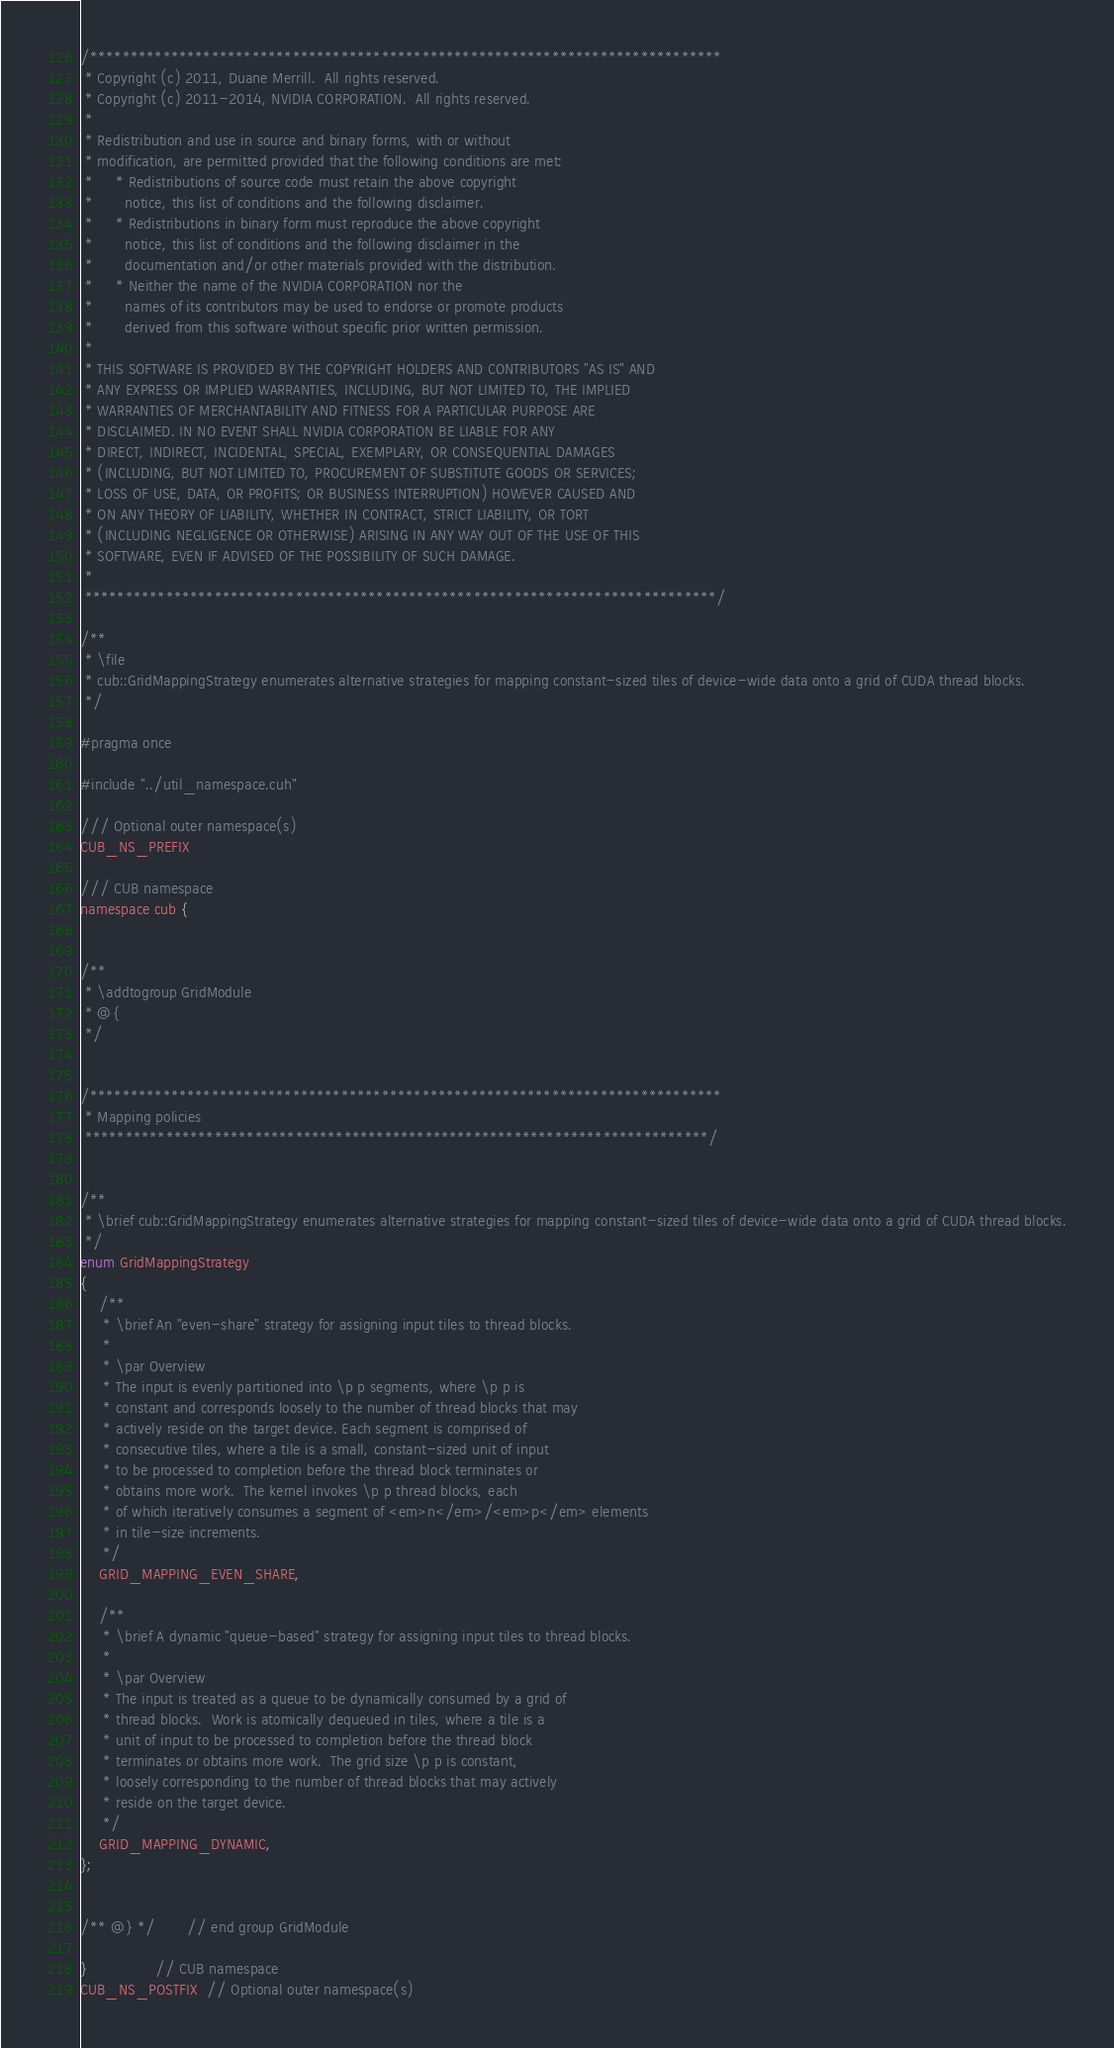Convert code to text. <code><loc_0><loc_0><loc_500><loc_500><_Cuda_>/******************************************************************************
 * Copyright (c) 2011, Duane Merrill.  All rights reserved.
 * Copyright (c) 2011-2014, NVIDIA CORPORATION.  All rights reserved.
 *
 * Redistribution and use in source and binary forms, with or without
 * modification, are permitted provided that the following conditions are met:
 *     * Redistributions of source code must retain the above copyright
 *       notice, this list of conditions and the following disclaimer.
 *     * Redistributions in binary form must reproduce the above copyright
 *       notice, this list of conditions and the following disclaimer in the
 *       documentation and/or other materials provided with the distribution.
 *     * Neither the name of the NVIDIA CORPORATION nor the
 *       names of its contributors may be used to endorse or promote products
 *       derived from this software without specific prior written permission.
 *
 * THIS SOFTWARE IS PROVIDED BY THE COPYRIGHT HOLDERS AND CONTRIBUTORS "AS IS" AND
 * ANY EXPRESS OR IMPLIED WARRANTIES, INCLUDING, BUT NOT LIMITED TO, THE IMPLIED
 * WARRANTIES OF MERCHANTABILITY AND FITNESS FOR A PARTICULAR PURPOSE ARE
 * DISCLAIMED. IN NO EVENT SHALL NVIDIA CORPORATION BE LIABLE FOR ANY
 * DIRECT, INDIRECT, INCIDENTAL, SPECIAL, EXEMPLARY, OR CONSEQUENTIAL DAMAGES
 * (INCLUDING, BUT NOT LIMITED TO, PROCUREMENT OF SUBSTITUTE GOODS OR SERVICES;
 * LOSS OF USE, DATA, OR PROFITS; OR BUSINESS INTERRUPTION) HOWEVER CAUSED AND
 * ON ANY THEORY OF LIABILITY, WHETHER IN CONTRACT, STRICT LIABILITY, OR TORT
 * (INCLUDING NEGLIGENCE OR OTHERWISE) ARISING IN ANY WAY OUT OF THE USE OF THIS
 * SOFTWARE, EVEN IF ADVISED OF THE POSSIBILITY OF SUCH DAMAGE.
 *
 ******************************************************************************/

/**
 * \file
 * cub::GridMappingStrategy enumerates alternative strategies for mapping constant-sized tiles of device-wide data onto a grid of CUDA thread blocks.
 */

#pragma once

#include "../util_namespace.cuh"

/// Optional outer namespace(s)
CUB_NS_PREFIX

/// CUB namespace
namespace cub {


/**
 * \addtogroup GridModule
 * @{
 */


/******************************************************************************
 * Mapping policies
 *****************************************************************************/


/**
 * \brief cub::GridMappingStrategy enumerates alternative strategies for mapping constant-sized tiles of device-wide data onto a grid of CUDA thread blocks.
 */
enum GridMappingStrategy
{
    /**
     * \brief An "even-share" strategy for assigning input tiles to thread blocks.
     *
     * \par Overview
     * The input is evenly partitioned into \p p segments, where \p p is
     * constant and corresponds loosely to the number of thread blocks that may
     * actively reside on the target device. Each segment is comprised of
     * consecutive tiles, where a tile is a small, constant-sized unit of input
     * to be processed to completion before the thread block terminates or
     * obtains more work.  The kernel invokes \p p thread blocks, each
     * of which iteratively consumes a segment of <em>n</em>/<em>p</em> elements
     * in tile-size increments.
     */
    GRID_MAPPING_EVEN_SHARE,

    /**
     * \brief A dynamic "queue-based" strategy for assigning input tiles to thread blocks.
     *
     * \par Overview
     * The input is treated as a queue to be dynamically consumed by a grid of
     * thread blocks.  Work is atomically dequeued in tiles, where a tile is a
     * unit of input to be processed to completion before the thread block
     * terminates or obtains more work.  The grid size \p p is constant,
     * loosely corresponding to the number of thread blocks that may actively
     * reside on the target device.
     */
    GRID_MAPPING_DYNAMIC,
};


/** @} */       // end group GridModule

}               // CUB namespace
CUB_NS_POSTFIX  // Optional outer namespace(s)

</code> 